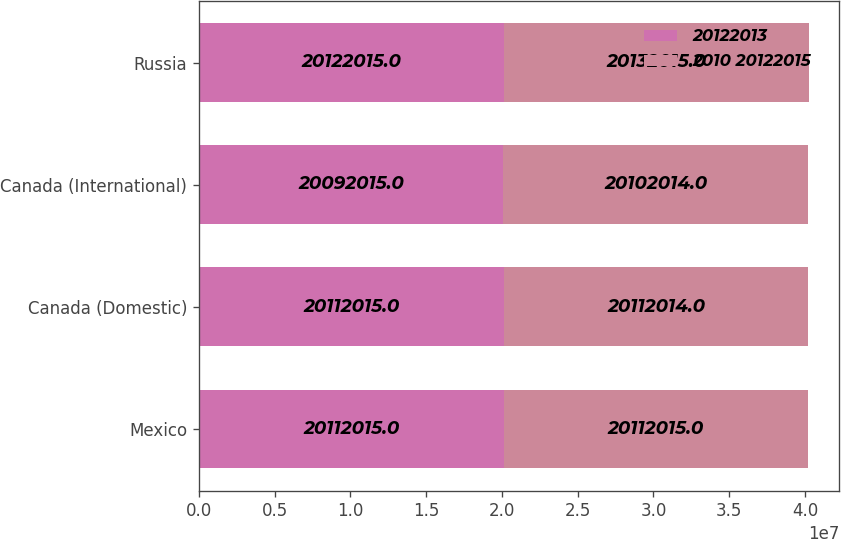<chart> <loc_0><loc_0><loc_500><loc_500><stacked_bar_chart><ecel><fcel>Mexico<fcel>Canada (Domestic)<fcel>Canada (International)<fcel>Russia<nl><fcel>20122013<fcel>2.0112e+07<fcel>2.0112e+07<fcel>2.0092e+07<fcel>2.0122e+07<nl><fcel>2010 20122015<fcel>2.0112e+07<fcel>2.0112e+07<fcel>2.0102e+07<fcel>2.0132e+07<nl></chart> 